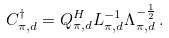<formula> <loc_0><loc_0><loc_500><loc_500>C _ { \pi , d } ^ { \dagger } = Q _ { \pi , d } ^ { H } L _ { \pi , d } ^ { - 1 } \Lambda _ { \pi , d } ^ { - \frac { 1 } { 2 } } \, .</formula> 